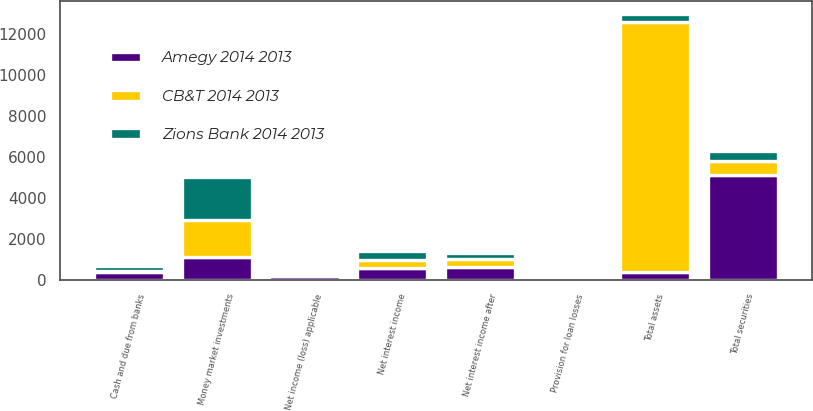Convert chart. <chart><loc_0><loc_0><loc_500><loc_500><stacked_bar_chart><ecel><fcel>Net interest income<fcel>Provision for loan losses<fcel>Net interest income after<fcel>Net income (loss) applicable<fcel>Total assets<fcel>Cash and due from banks<fcel>Money market investments<fcel>Total securities<nl><fcel>Amegy 2014 2013<fcel>583<fcel>28.3<fcel>611.3<fcel>149.4<fcel>393<fcel>375<fcel>1118<fcel>5103<nl><fcel>Zions Bank 2014 2013<fcel>398<fcel>91.3<fcel>306.7<fcel>44.8<fcel>393<fcel>228<fcel>2072<fcel>465<nl><fcel>CB&T 2014 2013<fcel>390.8<fcel>4.4<fcel>395.2<fcel>106.2<fcel>12187<fcel>56<fcel>1814<fcel>714<nl></chart> 